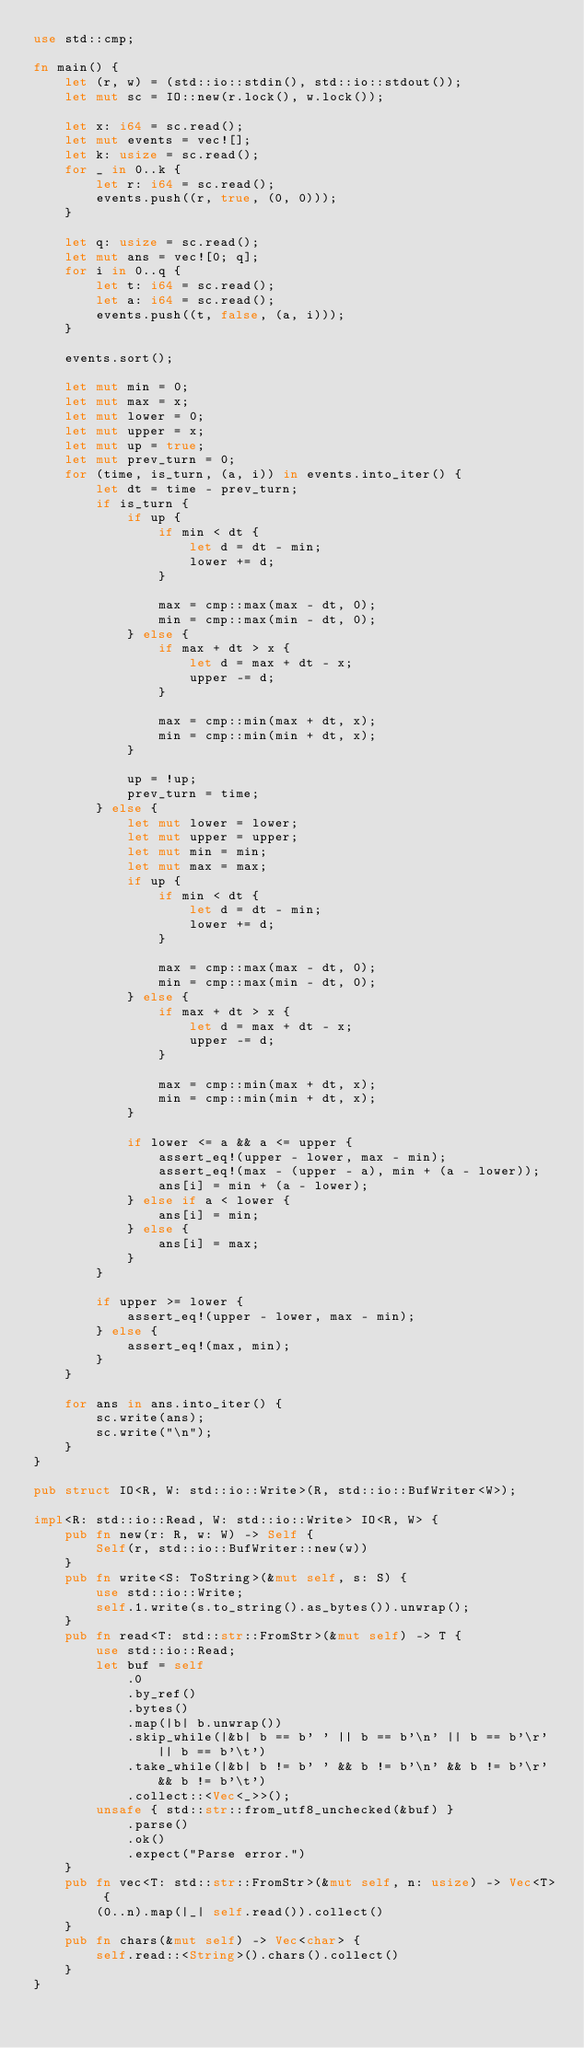<code> <loc_0><loc_0><loc_500><loc_500><_Rust_>use std::cmp;

fn main() {
    let (r, w) = (std::io::stdin(), std::io::stdout());
    let mut sc = IO::new(r.lock(), w.lock());

    let x: i64 = sc.read();
    let mut events = vec![];
    let k: usize = sc.read();
    for _ in 0..k {
        let r: i64 = sc.read();
        events.push((r, true, (0, 0)));
    }

    let q: usize = sc.read();
    let mut ans = vec![0; q];
    for i in 0..q {
        let t: i64 = sc.read();
        let a: i64 = sc.read();
        events.push((t, false, (a, i)));
    }

    events.sort();

    let mut min = 0;
    let mut max = x;
    let mut lower = 0;
    let mut upper = x;
    let mut up = true;
    let mut prev_turn = 0;
    for (time, is_turn, (a, i)) in events.into_iter() {
        let dt = time - prev_turn;
        if is_turn {
            if up {
                if min < dt {
                    let d = dt - min;
                    lower += d;
                }

                max = cmp::max(max - dt, 0);
                min = cmp::max(min - dt, 0);
            } else {
                if max + dt > x {
                    let d = max + dt - x;
                    upper -= d;
                }

                max = cmp::min(max + dt, x);
                min = cmp::min(min + dt, x);
            }

            up = !up;
            prev_turn = time;
        } else {
            let mut lower = lower;
            let mut upper = upper;
            let mut min = min;
            let mut max = max;
            if up {
                if min < dt {
                    let d = dt - min;
                    lower += d;
                }

                max = cmp::max(max - dt, 0);
                min = cmp::max(min - dt, 0);
            } else {
                if max + dt > x {
                    let d = max + dt - x;
                    upper -= d;
                }

                max = cmp::min(max + dt, x);
                min = cmp::min(min + dt, x);
            }

            if lower <= a && a <= upper {
                assert_eq!(upper - lower, max - min);
                assert_eq!(max - (upper - a), min + (a - lower));
                ans[i] = min + (a - lower);
            } else if a < lower {
                ans[i] = min;
            } else {
                ans[i] = max;
            }
        }

        if upper >= lower {
            assert_eq!(upper - lower, max - min);
        } else {
            assert_eq!(max, min);
        }
    }

    for ans in ans.into_iter() {
        sc.write(ans);
        sc.write("\n");
    }
}

pub struct IO<R, W: std::io::Write>(R, std::io::BufWriter<W>);

impl<R: std::io::Read, W: std::io::Write> IO<R, W> {
    pub fn new(r: R, w: W) -> Self {
        Self(r, std::io::BufWriter::new(w))
    }
    pub fn write<S: ToString>(&mut self, s: S) {
        use std::io::Write;
        self.1.write(s.to_string().as_bytes()).unwrap();
    }
    pub fn read<T: std::str::FromStr>(&mut self) -> T {
        use std::io::Read;
        let buf = self
            .0
            .by_ref()
            .bytes()
            .map(|b| b.unwrap())
            .skip_while(|&b| b == b' ' || b == b'\n' || b == b'\r' || b == b'\t')
            .take_while(|&b| b != b' ' && b != b'\n' && b != b'\r' && b != b'\t')
            .collect::<Vec<_>>();
        unsafe { std::str::from_utf8_unchecked(&buf) }
            .parse()
            .ok()
            .expect("Parse error.")
    }
    pub fn vec<T: std::str::FromStr>(&mut self, n: usize) -> Vec<T> {
        (0..n).map(|_| self.read()).collect()
    }
    pub fn chars(&mut self) -> Vec<char> {
        self.read::<String>().chars().collect()
    }
}
</code> 